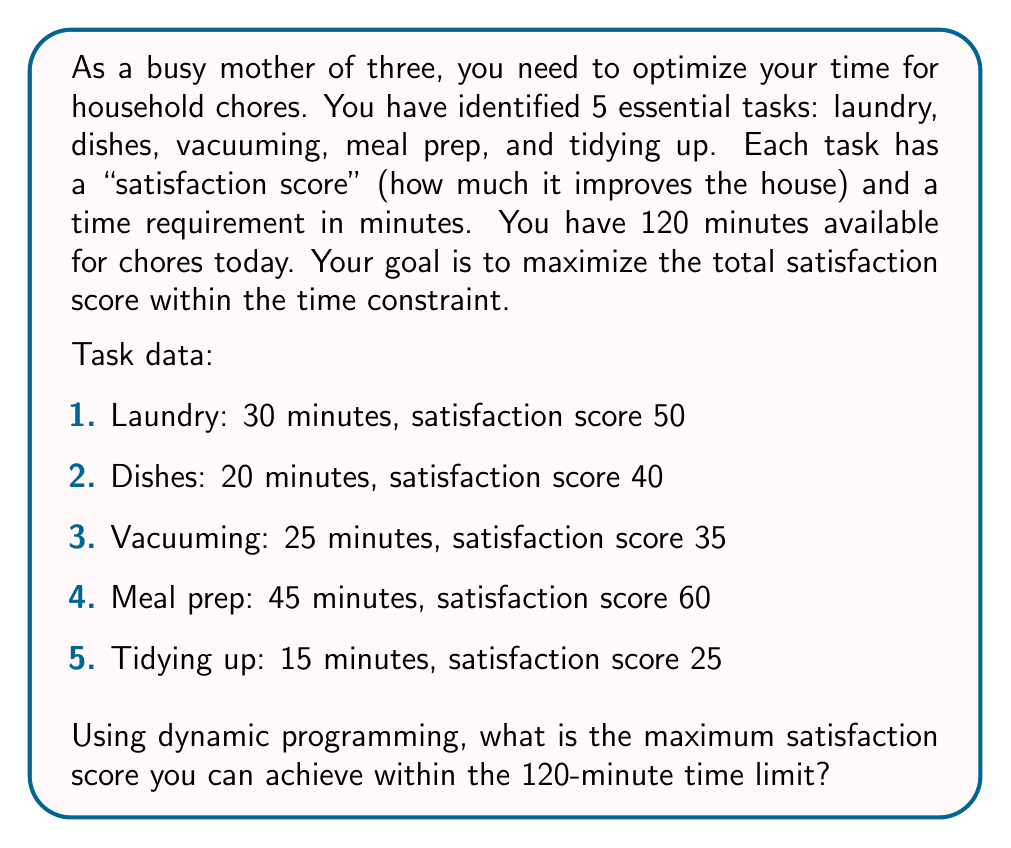Provide a solution to this math problem. To solve this problem using dynamic programming, we'll create a table where rows represent tasks and columns represent time intervals. We'll fill this table with the maximum satisfaction scores achievable for each time interval.

Let's define our dynamic programming function:

$$ f(i, t) = \max\begin{cases} 
f(i-1, t) & \text{if we don't include task i} \\
f(i-1, t-t_i) + s_i & \text{if we include task i}
\end{cases} $$

Where:
- $i$ is the current task
- $t$ is the available time
- $t_i$ is the time required for task $i$
- $s_i$ is the satisfaction score for task $i$

We'll create a table with 6 rows (0 to 5 tasks) and 121 columns (0 to 120 minutes).

1. Initialize the first row and column with zeros.
2. For each task and each time interval:
   a. If the task's time requirement is greater than the available time, copy the value from the cell above.
   b. Otherwise, take the maximum of:
      - The value from the cell above (not including the current task)
      - The sum of the current task's satisfaction score and the best score achievable with the remaining time (including the current task)

Here's a partial view of the filled table:

$$
\begin{array}{c|cccccccc}
\text{Task} \backslash \text{Time} & 0 & 15 & 20 & 25 & 30 & \cdots & 120 \\
\hline
0 & 0 & 0 & 0 & 0 & 0 & \cdots & 0 \\
1 \text{ (Laundry)} & 0 & 0 & 0 & 0 & 50 & \cdots & 50 \\
2 \text{ (Dishes)} & 0 & 0 & 40 & 40 & 50 & \cdots & 90 \\
3 \text{ (Vacuuming)} & 0 & 0 & 40 & 40 & 50 & \cdots & 125 \\
4 \text{ (Meal prep)} & 0 & 0 & 40 & 40 & 50 & \cdots & 150 \\
5 \text{ (Tidying up)} & 0 & 25 & 40 & 65 & 65 & \cdots & 175 \\
\end{array}
$$

The final answer is found in the bottom-right cell of the completed table.
Answer: The maximum satisfaction score achievable within 120 minutes is 175. 